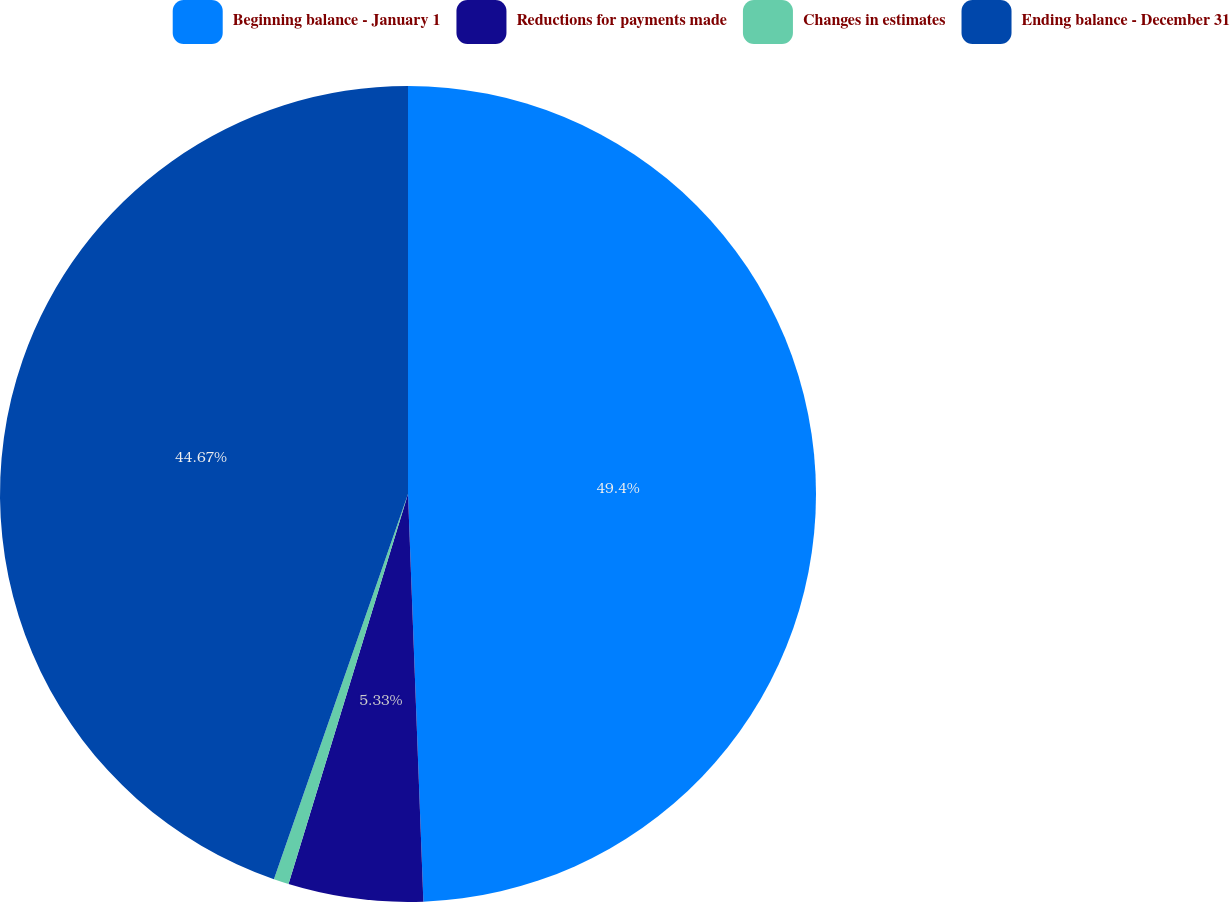<chart> <loc_0><loc_0><loc_500><loc_500><pie_chart><fcel>Beginning balance - January 1<fcel>Reductions for payments made<fcel>Changes in estimates<fcel>Ending balance - December 31<nl><fcel>49.4%<fcel>5.33%<fcel>0.6%<fcel>44.67%<nl></chart> 